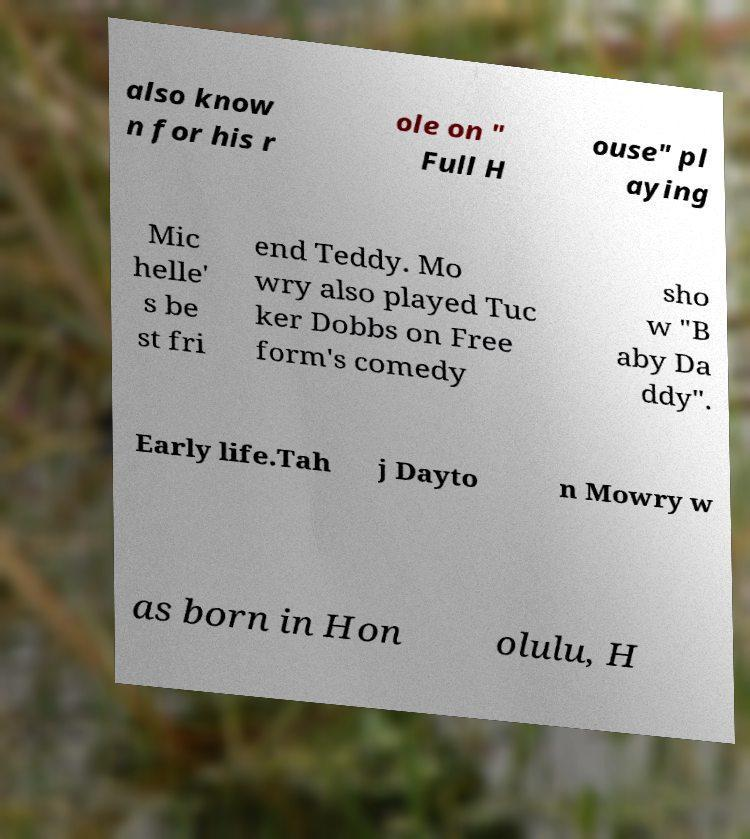For documentation purposes, I need the text within this image transcribed. Could you provide that? also know n for his r ole on " Full H ouse" pl aying Mic helle' s be st fri end Teddy. Mo wry also played Tuc ker Dobbs on Free form's comedy sho w "B aby Da ddy". Early life.Tah j Dayto n Mowry w as born in Hon olulu, H 